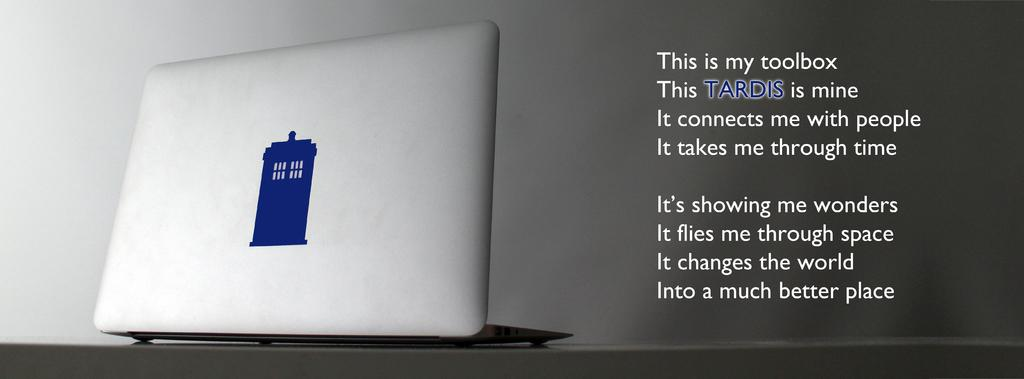What electronic device is present in the image? There is a laptop in the image. On what surface is the laptop placed? The laptop is on a surface that resembles a table. What can be seen on the laptop's screen? There is text visible in the image. What is visible in the background of the image? There is a wall in the background of the image. How many baskets of sand are present in the image? There are no baskets or sand present in the image. 